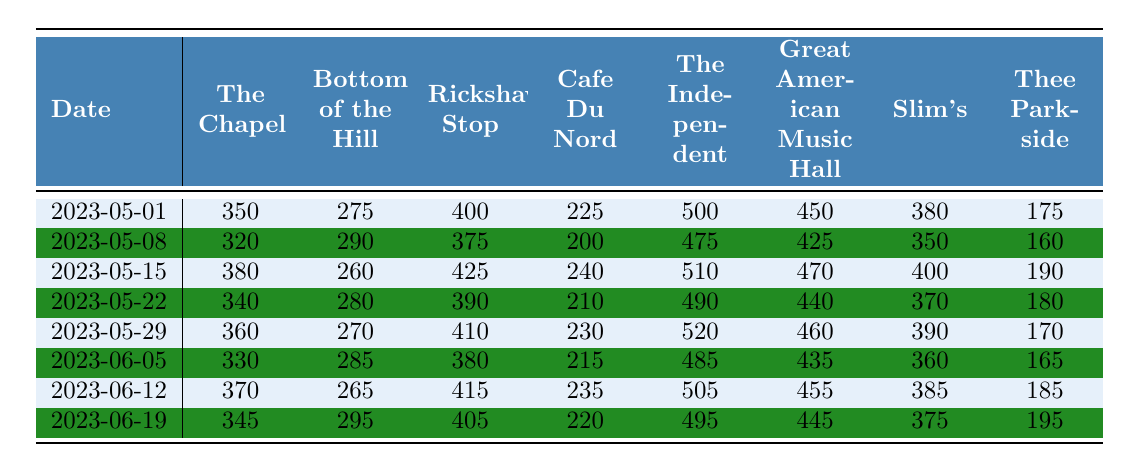What was the attendance at The Chapel on May 15, 2023? The table shows a value for The Chapel on the date 2023-05-15, which is listed as 380.
Answer: 380 Which venue had the highest attendance on May 29, 2023? On May 29, 2023, the attendances for the venues are: The Chapel - 360, Bottom of the Hill - 270, Rickshaw Stop - 410, Cafe Du Nord - 230, The Independent - 520, Great American Music Hall - 460, Slim's - 390, Thee Parkside - 170. The highest value is 520 for The Independent.
Answer: The Independent What was the average attendance for Rickshaw Stop over all dates? The attendance figures for Rickshaw Stop are: 400, 375, 425, 390, 410, 380, 415, and 405. Summing these values gives 3,000. There are 8 dates, so the average attendance is 3,000/8 = 375.
Answer: 375 Did Slim's have an attendance higher than 400 on any of the dates? Checking the attendance for Slim's: 380, 350, 400, 370, 390, 360, 385, 375. None of these values are higher than 400, so the answer is no.
Answer: No Which venue had the lowest attendance on June 5, 2023? On June 5, 2023, the attendance figures are as follows: The Chapel - 330, Bottom of the Hill - 285, Rickshaw Stop - 380, Cafe Du Nord - 215, The Independent - 485, Great American Music Hall - 435, Slim's - 360, Thee Parkside - 165. The lowest value is 165 for Thee Parkside.
Answer: Thee Parkside What was the total attendance for all venues on May 22, 2023? On May 22, 2023, the attendances are: The Chapel - 340, Bottom of the Hill - 280, Rickshaw Stop - 390, Cafe Du Nord - 210, The Independent - 490, Great American Music Hall - 440, Slim's - 370, Thee Parkside - 180. Summing these figures gives a total of 2,250.
Answer: 2250 What was the increase in attendance at Great American Music Hall from May 1 to June 19, 2023? The attendance on May 1, 2023, at Great American Music Hall was 450, and on June 19, 2023, it was 445. The increase (or decrease in this case) is calculated by 445 - 450 = -5, indicating a decrease.
Answer: Decrease of 5 Which venue had a consistent attendance of 375 or more over the selected dates? Looking at the attendance for all dates for each venue, Rickshaw Stop has: 400, 375, 425, 390, 410, 380, 415, and 405—all of which are greater than or equal to 375. Therefore, Rickshaw Stop is the venue that meets this condition.
Answer: Rickshaw Stop What was the coupled attendance for The Chapel and The Independent on May 15, 2023? On May 15, 2023, The Chapel had 380 and The Independent had 510. Adding these values gives 380 + 510 = 890.
Answer: 890 